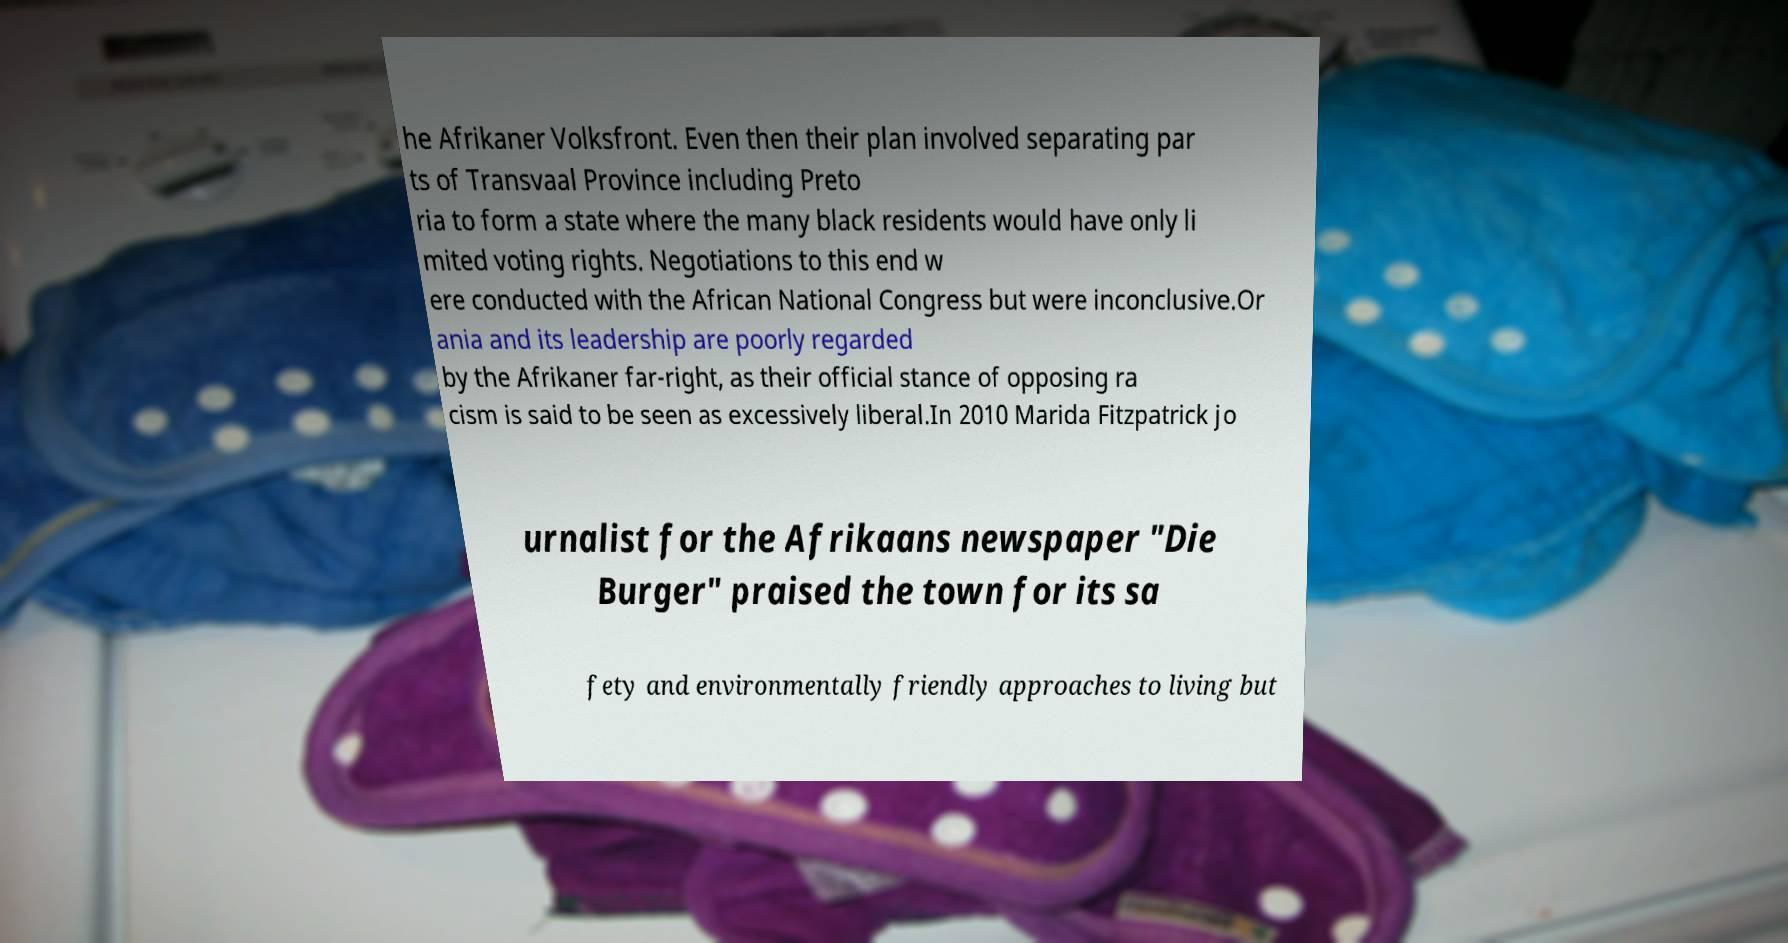Could you extract and type out the text from this image? he Afrikaner Volksfront. Even then their plan involved separating par ts of Transvaal Province including Preto ria to form a state where the many black residents would have only li mited voting rights. Negotiations to this end w ere conducted with the African National Congress but were inconclusive.Or ania and its leadership are poorly regarded by the Afrikaner far-right, as their official stance of opposing ra cism is said to be seen as excessively liberal.In 2010 Marida Fitzpatrick jo urnalist for the Afrikaans newspaper "Die Burger" praised the town for its sa fety and environmentally friendly approaches to living but 